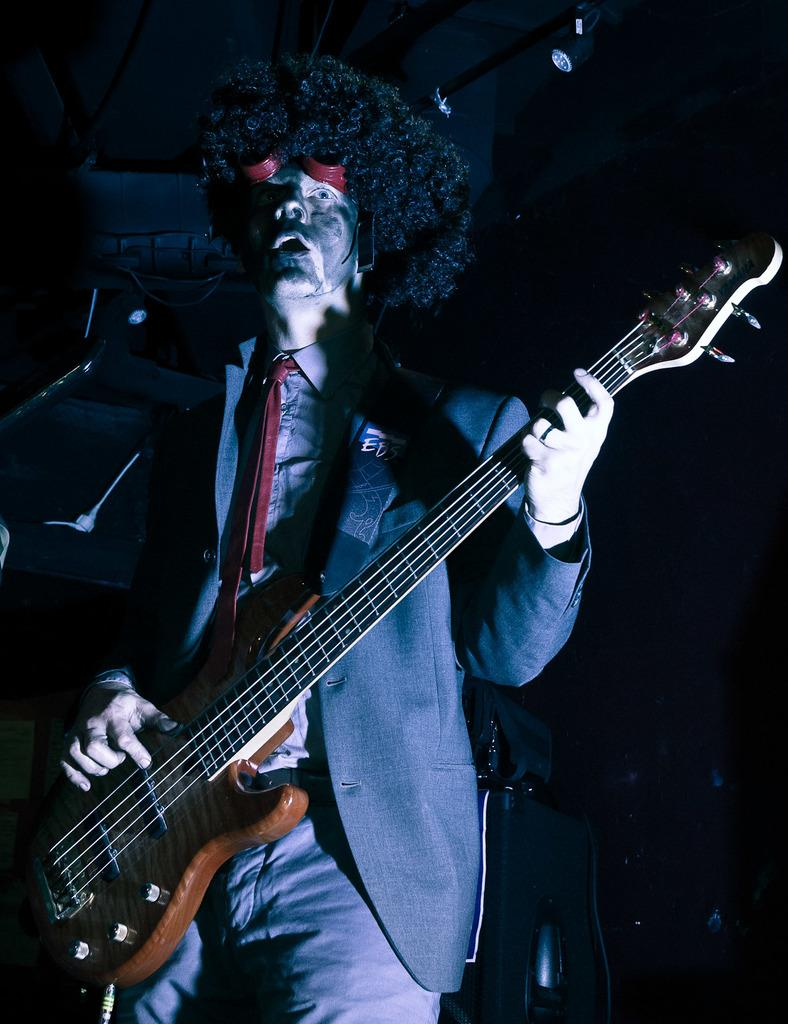What is the main subject of the image? There is a man in the image. What is the man doing in the image? The man is playing a guitar. Can you see a boat in the image? There is no boat present in the image; it only features a man playing a guitar. What type of clouds can be seen in the image? There are no clouds visible in the image, as it only shows a man playing a guitar. 